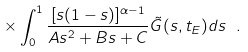<formula> <loc_0><loc_0><loc_500><loc_500>\quad \ \times \int _ { 0 } ^ { 1 } { \frac { [ s ( 1 - s ) ] ^ { \alpha - 1 } } { A s ^ { 2 } + B s + C } \tilde { G } ( s , t _ { E } ) d s } \ .</formula> 